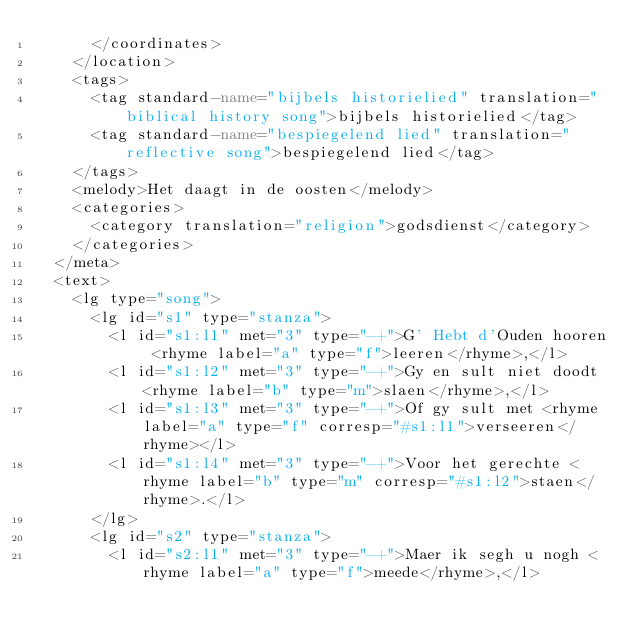<code> <loc_0><loc_0><loc_500><loc_500><_XML_>      </coordinates>
    </location>
    <tags>
      <tag standard-name="bijbels historielied" translation="biblical history song">bijbels historielied</tag>
      <tag standard-name="bespiegelend lied" translation="reflective song">bespiegelend lied</tag>
    </tags>
    <melody>Het daagt in de oosten</melody>
    <categories>
      <category translation="religion">godsdienst</category>
    </categories>
  </meta>
  <text>
    <lg type="song">
      <lg id="s1" type="stanza">
        <l id="s1:l1" met="3" type="-+">G' Hebt d'Ouden hooren <rhyme label="a" type="f">leeren</rhyme>,</l>
        <l id="s1:l2" met="3" type="-+">Gy en sult niet doodt <rhyme label="b" type="m">slaen</rhyme>,</l>
        <l id="s1:l3" met="3" type="-+">Of gy sult met <rhyme label="a" type="f" corresp="#s1:l1">verseeren</rhyme></l>
        <l id="s1:l4" met="3" type="-+">Voor het gerechte <rhyme label="b" type="m" corresp="#s1:l2">staen</rhyme>.</l>
      </lg>
      <lg id="s2" type="stanza">
        <l id="s2:l1" met="3" type="-+">Maer ik segh u nogh <rhyme label="a" type="f">meede</rhyme>,</l></code> 